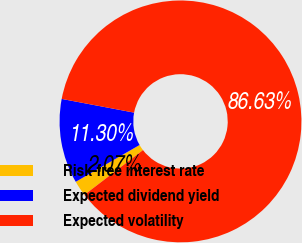Convert chart. <chart><loc_0><loc_0><loc_500><loc_500><pie_chart><fcel>Risk-free interest rate<fcel>Expected dividend yield<fcel>Expected volatility<nl><fcel>2.07%<fcel>11.3%<fcel>86.64%<nl></chart> 